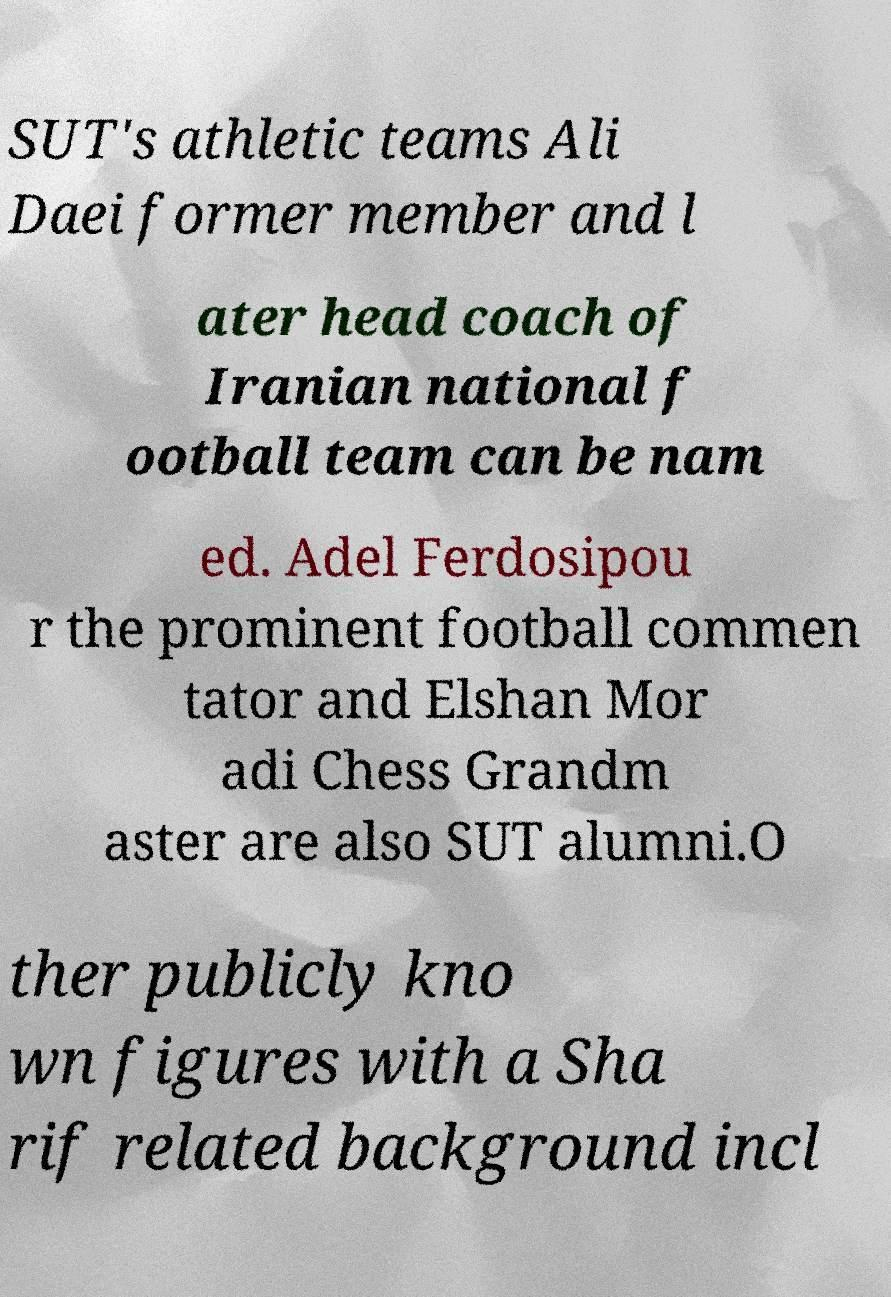Please read and relay the text visible in this image. What does it say? SUT's athletic teams Ali Daei former member and l ater head coach of Iranian national f ootball team can be nam ed. Adel Ferdosipou r the prominent football commen tator and Elshan Mor adi Chess Grandm aster are also SUT alumni.O ther publicly kno wn figures with a Sha rif related background incl 